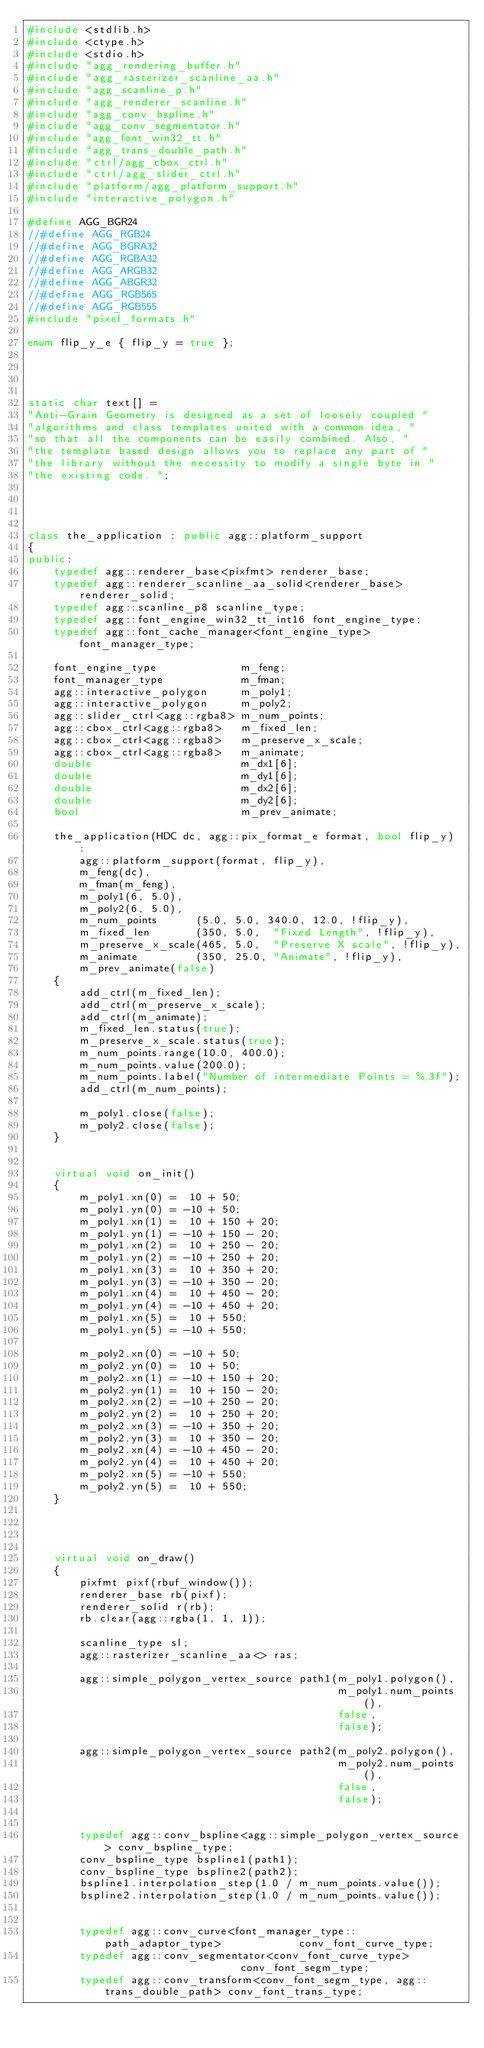<code> <loc_0><loc_0><loc_500><loc_500><_C++_>#include <stdlib.h>
#include <ctype.h>
#include <stdio.h>
#include "agg_rendering_buffer.h"
#include "agg_rasterizer_scanline_aa.h"
#include "agg_scanline_p.h"
#include "agg_renderer_scanline.h"
#include "agg_conv_bspline.h"
#include "agg_conv_segmentator.h"
#include "agg_font_win32_tt.h"
#include "agg_trans_double_path.h"
#include "ctrl/agg_cbox_ctrl.h"
#include "ctrl/agg_slider_ctrl.h"
#include "platform/agg_platform_support.h"
#include "interactive_polygon.h"

#define AGG_BGR24 
//#define AGG_RGB24
//#define AGG_BGRA32 
//#define AGG_RGBA32 
//#define AGG_ARGB32 
//#define AGG_ABGR32
//#define AGG_RGB565
//#define AGG_RGB555
#include "pixel_formats.h"

enum flip_y_e { flip_y = true };




static char text[] = 
"Anti-Grain Geometry is designed as a set of loosely coupled "
"algorithms and class templates united with a common idea, "
"so that all the components can be easily combined. Also, "
"the template based design allows you to replace any part of "
"the library without the necessity to modify a single byte in "
"the existing code. ";




class the_application : public agg::platform_support
{
public:
    typedef agg::renderer_base<pixfmt> renderer_base;
    typedef agg::renderer_scanline_aa_solid<renderer_base> renderer_solid;
    typedef agg::scanline_p8 scanline_type;
    typedef agg::font_engine_win32_tt_int16 font_engine_type;
    typedef agg::font_cache_manager<font_engine_type> font_manager_type;

    font_engine_type             m_feng;
    font_manager_type            m_fman;
    agg::interactive_polygon     m_poly1;
    agg::interactive_polygon     m_poly2;
    agg::slider_ctrl<agg::rgba8> m_num_points;
    agg::cbox_ctrl<agg::rgba8>   m_fixed_len;
    agg::cbox_ctrl<agg::rgba8>   m_preserve_x_scale;
    agg::cbox_ctrl<agg::rgba8>   m_animate;
    double                       m_dx1[6];
    double                       m_dy1[6];
    double                       m_dx2[6];
    double                       m_dy2[6];
    bool                         m_prev_animate;

    the_application(HDC dc, agg::pix_format_e format, bool flip_y) :
        agg::platform_support(format, flip_y),
        m_feng(dc),
        m_fman(m_feng),
        m_poly1(6, 5.0),
        m_poly2(6, 5.0),
        m_num_points      (5.0, 5.0, 340.0, 12.0, !flip_y),
        m_fixed_len       (350, 5.0,  "Fixed Length", !flip_y),
        m_preserve_x_scale(465, 5.0,  "Preserve X scale", !flip_y),
        m_animate         (350, 25.0, "Animate", !flip_y),
        m_prev_animate(false)
    {
        add_ctrl(m_fixed_len);
        add_ctrl(m_preserve_x_scale);
        add_ctrl(m_animate);
        m_fixed_len.status(true);
        m_preserve_x_scale.status(true);
        m_num_points.range(10.0, 400.0);
        m_num_points.value(200.0);
        m_num_points.label("Number of intermediate Points = %.3f");
        add_ctrl(m_num_points);

        m_poly1.close(false);
        m_poly2.close(false);
    }


    virtual void on_init()
    {
        m_poly1.xn(0) =  10 + 50;
        m_poly1.yn(0) = -10 + 50;
        m_poly1.xn(1) =  10 + 150 + 20;
        m_poly1.yn(1) = -10 + 150 - 20;
        m_poly1.xn(2) =  10 + 250 - 20;
        m_poly1.yn(2) = -10 + 250 + 20;
        m_poly1.xn(3) =  10 + 350 + 20;
        m_poly1.yn(3) = -10 + 350 - 20;
        m_poly1.xn(4) =  10 + 450 - 20;
        m_poly1.yn(4) = -10 + 450 + 20;
        m_poly1.xn(5) =  10 + 550;
        m_poly1.yn(5) = -10 + 550;

        m_poly2.xn(0) = -10 + 50;
        m_poly2.yn(0) =  10 + 50;
        m_poly2.xn(1) = -10 + 150 + 20;
        m_poly2.yn(1) =  10 + 150 - 20;
        m_poly2.xn(2) = -10 + 250 - 20;
        m_poly2.yn(2) =  10 + 250 + 20;
        m_poly2.xn(3) = -10 + 350 + 20;
        m_poly2.yn(3) =  10 + 350 - 20;
        m_poly2.xn(4) = -10 + 450 - 20;
        m_poly2.yn(4) =  10 + 450 + 20;
        m_poly2.xn(5) = -10 + 550;
        m_poly2.yn(5) =  10 + 550;
    }




    virtual void on_draw()
    {
        pixfmt pixf(rbuf_window());
        renderer_base rb(pixf);
        renderer_solid r(rb);
        rb.clear(agg::rgba(1, 1, 1));

        scanline_type sl;
        agg::rasterizer_scanline_aa<> ras;

        agg::simple_polygon_vertex_source path1(m_poly1.polygon(), 
                                                m_poly1.num_points(), 
                                                false, 
                                                false);

        agg::simple_polygon_vertex_source path2(m_poly2.polygon(), 
                                                m_poly2.num_points(), 
                                                false, 
                                                false);


        typedef agg::conv_bspline<agg::simple_polygon_vertex_source> conv_bspline_type;
        conv_bspline_type bspline1(path1);
        conv_bspline_type bspline2(path2);
        bspline1.interpolation_step(1.0 / m_num_points.value());
        bspline2.interpolation_step(1.0 / m_num_points.value());


        typedef agg::conv_curve<font_manager_type::path_adaptor_type>            conv_font_curve_type;
        typedef agg::conv_segmentator<conv_font_curve_type>                      conv_font_segm_type;
        typedef agg::conv_transform<conv_font_segm_type, agg::trans_double_path> conv_font_trans_type;
</code> 